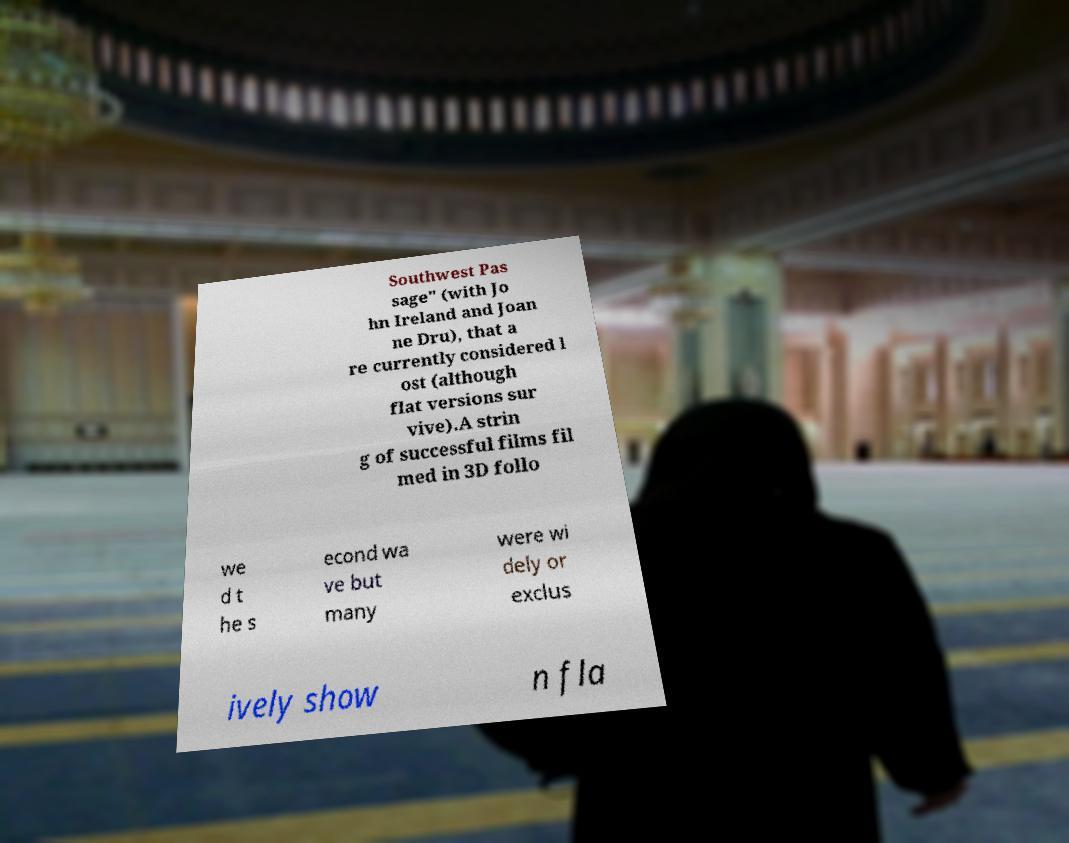What messages or text are displayed in this image? I need them in a readable, typed format. Southwest Pas sage" (with Jo hn Ireland and Joan ne Dru), that a re currently considered l ost (although flat versions sur vive).A strin g of successful films fil med in 3D follo we d t he s econd wa ve but many were wi dely or exclus ively show n fla 